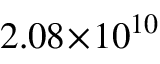<formula> <loc_0><loc_0><loc_500><loc_500>2 . 0 8 \, \times \, 1 0 ^ { 1 0 }</formula> 